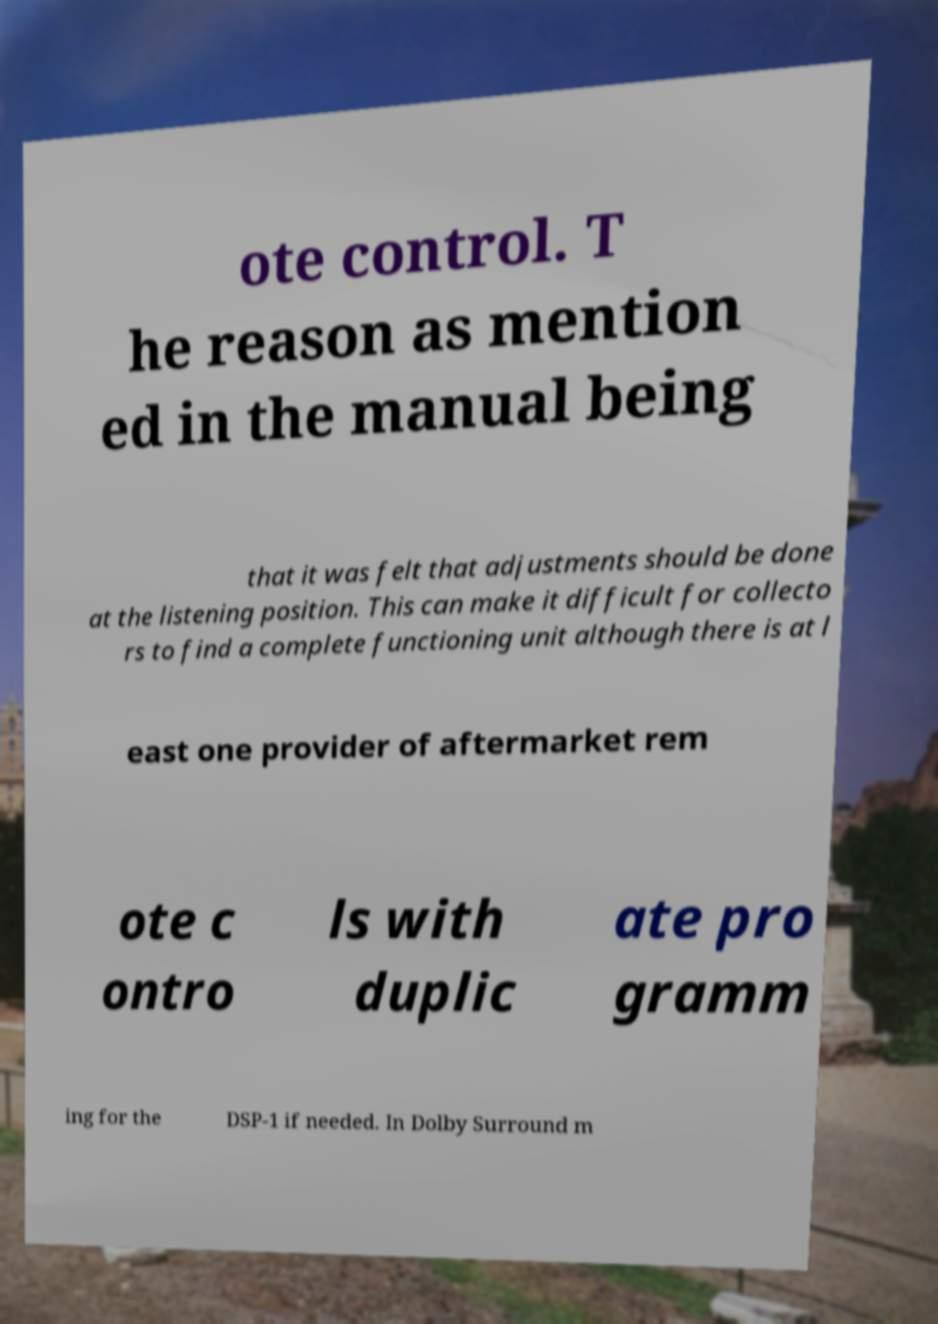Please read and relay the text visible in this image. What does it say? ote control. T he reason as mention ed in the manual being that it was felt that adjustments should be done at the listening position. This can make it difficult for collecto rs to find a complete functioning unit although there is at l east one provider of aftermarket rem ote c ontro ls with duplic ate pro gramm ing for the DSP-1 if needed. In Dolby Surround m 